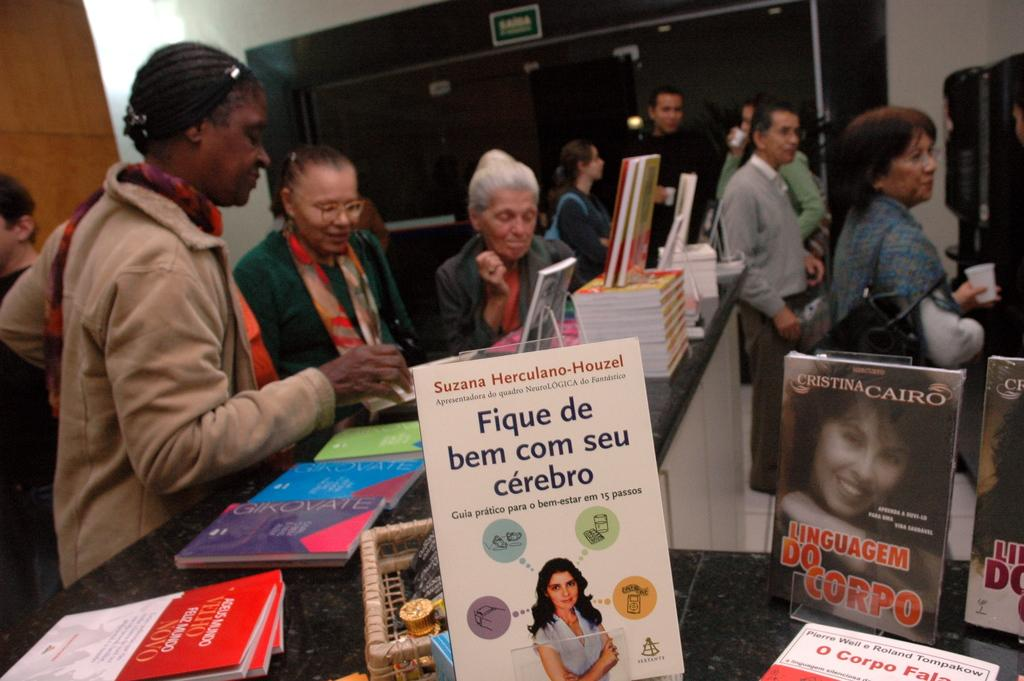<image>
Summarize the visual content of the image. A book called Fique de bem com seu cerebro featured among others is on display while people browse. 